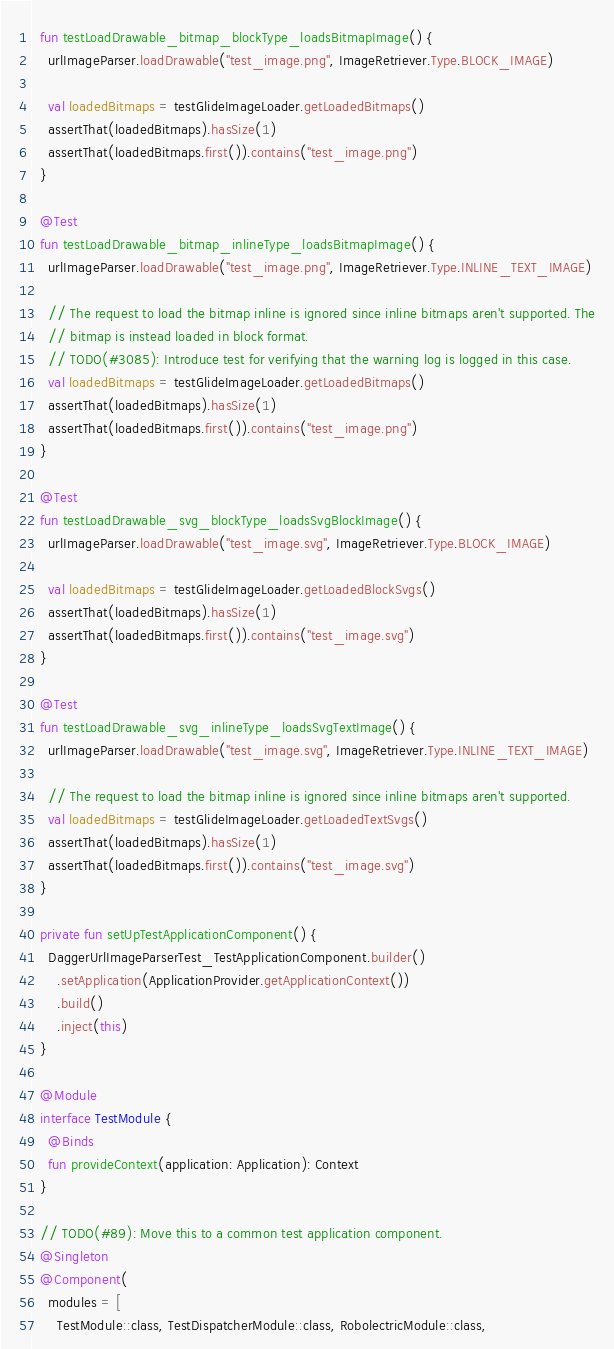<code> <loc_0><loc_0><loc_500><loc_500><_Kotlin_>  fun testLoadDrawable_bitmap_blockType_loadsBitmapImage() {
    urlImageParser.loadDrawable("test_image.png", ImageRetriever.Type.BLOCK_IMAGE)

    val loadedBitmaps = testGlideImageLoader.getLoadedBitmaps()
    assertThat(loadedBitmaps).hasSize(1)
    assertThat(loadedBitmaps.first()).contains("test_image.png")
  }

  @Test
  fun testLoadDrawable_bitmap_inlineType_loadsBitmapImage() {
    urlImageParser.loadDrawable("test_image.png", ImageRetriever.Type.INLINE_TEXT_IMAGE)

    // The request to load the bitmap inline is ignored since inline bitmaps aren't supported. The
    // bitmap is instead loaded in block format.
    // TODO(#3085): Introduce test for verifying that the warning log is logged in this case.
    val loadedBitmaps = testGlideImageLoader.getLoadedBitmaps()
    assertThat(loadedBitmaps).hasSize(1)
    assertThat(loadedBitmaps.first()).contains("test_image.png")
  }

  @Test
  fun testLoadDrawable_svg_blockType_loadsSvgBlockImage() {
    urlImageParser.loadDrawable("test_image.svg", ImageRetriever.Type.BLOCK_IMAGE)

    val loadedBitmaps = testGlideImageLoader.getLoadedBlockSvgs()
    assertThat(loadedBitmaps).hasSize(1)
    assertThat(loadedBitmaps.first()).contains("test_image.svg")
  }

  @Test
  fun testLoadDrawable_svg_inlineType_loadsSvgTextImage() {
    urlImageParser.loadDrawable("test_image.svg", ImageRetriever.Type.INLINE_TEXT_IMAGE)

    // The request to load the bitmap inline is ignored since inline bitmaps aren't supported.
    val loadedBitmaps = testGlideImageLoader.getLoadedTextSvgs()
    assertThat(loadedBitmaps).hasSize(1)
    assertThat(loadedBitmaps.first()).contains("test_image.svg")
  }

  private fun setUpTestApplicationComponent() {
    DaggerUrlImageParserTest_TestApplicationComponent.builder()
      .setApplication(ApplicationProvider.getApplicationContext())
      .build()
      .inject(this)
  }

  @Module
  interface TestModule {
    @Binds
    fun provideContext(application: Application): Context
  }

  // TODO(#89): Move this to a common test application component.
  @Singleton
  @Component(
    modules = [
      TestModule::class, TestDispatcherModule::class, RobolectricModule::class,</code> 